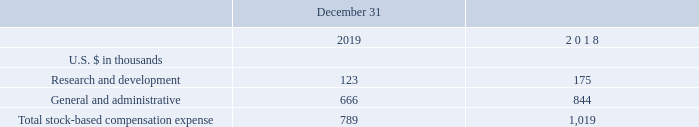NOTE 11 - STOCK CAPITAL (Cont.)
Shares and warrants issued to service providers:
On August 17, 2017 the Company issued to Anthony Fiorino, the former CEO of the Company, for consulting services rendered, a grant of 4,327 shares of restricted stock under the 2014 U.S. Plan, which vests in eight equal quarterly installments (starting November 17, 2017) until fully vested on the second anniversary of the date of grant.
Compensation expense recorded by the Company in respect of its stock-based service provider compensation awards for the year ended December 31, 2019 and 2018 amounted to $25 and $102, respectively.
On March 26, 2019, the Company issued to its legal advisor 5,908 shares of Common Stock under the 2014 U.S. Plan for certain 2018 legal services. The related compensation expense was recorded as general and administrative expense in 2018.
On May 23, 2019, the Company granted to a former director, in consideration for services rendered to the Company, an option under the 2014 Global Plan to purchase up to 4,167 shares of Common Stock with an exercise price per share of $0.75. The option was fully vested and exercisable as of the date of grant.
Total Stock-Based Compensation Expense:
The total stock-based compensation expense, related to shares, options and warrants granted to employees, directors and service providers was comprised, at each period, as follows:
What is the compensation expense recorded by the Company for the year ended December 31, 2019? $25. How many shares of the Common Stock were issued to the legal advisor on March 26, 2019? 5,908 shares of common stock. What is the exercise price per share under the 2014 Global Plan? $0.75. What is the change in the research and development stock-based compensation expense from 2018 to 2019?
Answer scale should be: thousand. 123-175
Answer: -52. What is the change in the general and administrative stock-based compensation expense from 2018 to 2019?
Answer scale should be: thousand. 666-844
Answer: -178. What is the percentage change in the total stock-based compensation expense from 2018 to 2019?
Answer scale should be: percent. (789-1,019)/1,019
Answer: -22.57. 